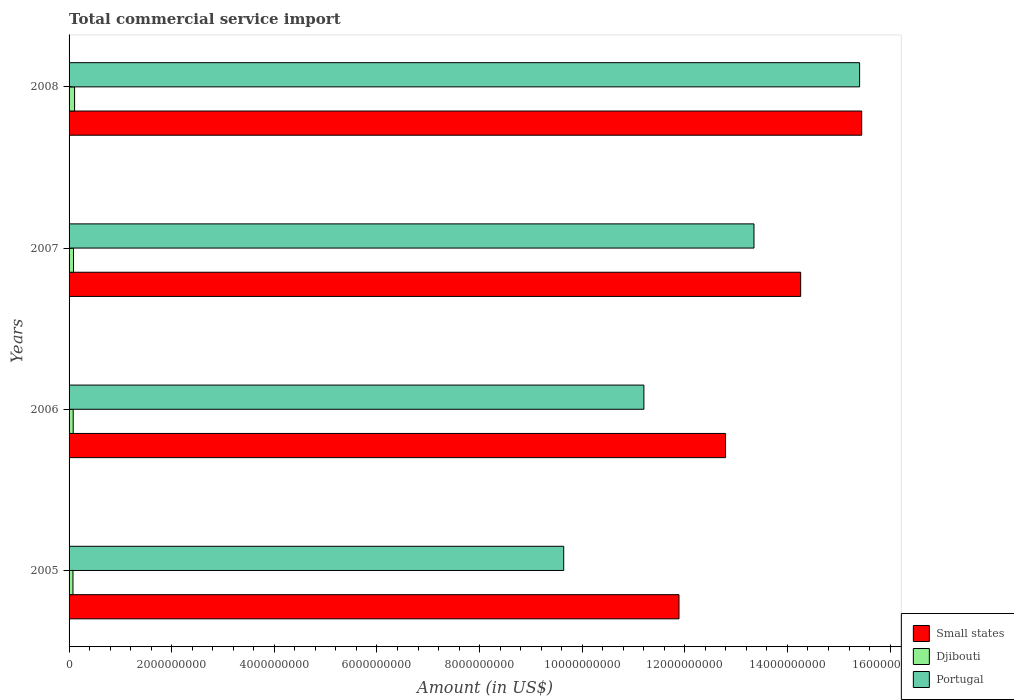How many different coloured bars are there?
Give a very brief answer. 3. How many groups of bars are there?
Keep it short and to the point. 4. Are the number of bars on each tick of the Y-axis equal?
Provide a short and direct response. Yes. How many bars are there on the 1st tick from the top?
Keep it short and to the point. 3. How many bars are there on the 2nd tick from the bottom?
Your answer should be very brief. 3. What is the label of the 1st group of bars from the top?
Offer a terse response. 2008. In how many cases, is the number of bars for a given year not equal to the number of legend labels?
Keep it short and to the point. 0. What is the total commercial service import in Small states in 2008?
Ensure brevity in your answer.  1.54e+1. Across all years, what is the maximum total commercial service import in Portugal?
Your answer should be very brief. 1.54e+1. Across all years, what is the minimum total commercial service import in Portugal?
Your answer should be very brief. 9.64e+09. In which year was the total commercial service import in Djibouti maximum?
Provide a short and direct response. 2008. In which year was the total commercial service import in Djibouti minimum?
Make the answer very short. 2005. What is the total total commercial service import in Portugal in the graph?
Your answer should be compact. 4.96e+1. What is the difference between the total commercial service import in Small states in 2005 and that in 2007?
Your answer should be compact. -2.37e+09. What is the difference between the total commercial service import in Small states in 2008 and the total commercial service import in Portugal in 2007?
Your answer should be very brief. 2.10e+09. What is the average total commercial service import in Djibouti per year?
Your answer should be compact. 8.77e+07. In the year 2006, what is the difference between the total commercial service import in Djibouti and total commercial service import in Small states?
Your answer should be compact. -1.27e+1. What is the ratio of the total commercial service import in Portugal in 2005 to that in 2006?
Your answer should be compact. 0.86. What is the difference between the highest and the second highest total commercial service import in Small states?
Provide a short and direct response. 1.19e+09. What is the difference between the highest and the lowest total commercial service import in Djibouti?
Give a very brief answer. 3.15e+07. What does the 3rd bar from the top in 2008 represents?
Provide a succinct answer. Small states. Are all the bars in the graph horizontal?
Ensure brevity in your answer.  Yes. Does the graph contain any zero values?
Your answer should be very brief. No. How many legend labels are there?
Your answer should be very brief. 3. How are the legend labels stacked?
Provide a succinct answer. Vertical. What is the title of the graph?
Offer a very short reply. Total commercial service import. What is the label or title of the X-axis?
Provide a succinct answer. Amount (in US$). What is the label or title of the Y-axis?
Provide a short and direct response. Years. What is the Amount (in US$) in Small states in 2005?
Keep it short and to the point. 1.19e+1. What is the Amount (in US$) in Djibouti in 2005?
Your answer should be compact. 7.61e+07. What is the Amount (in US$) in Portugal in 2005?
Offer a very short reply. 9.64e+09. What is the Amount (in US$) in Small states in 2006?
Your answer should be very brief. 1.28e+1. What is the Amount (in US$) of Djibouti in 2006?
Offer a terse response. 8.07e+07. What is the Amount (in US$) of Portugal in 2006?
Your response must be concise. 1.12e+1. What is the Amount (in US$) in Small states in 2007?
Offer a terse response. 1.43e+1. What is the Amount (in US$) in Djibouti in 2007?
Your response must be concise. 8.67e+07. What is the Amount (in US$) in Portugal in 2007?
Your answer should be compact. 1.33e+1. What is the Amount (in US$) of Small states in 2008?
Your answer should be compact. 1.54e+1. What is the Amount (in US$) of Djibouti in 2008?
Your answer should be compact. 1.08e+08. What is the Amount (in US$) of Portugal in 2008?
Offer a terse response. 1.54e+1. Across all years, what is the maximum Amount (in US$) of Small states?
Your response must be concise. 1.54e+1. Across all years, what is the maximum Amount (in US$) of Djibouti?
Provide a short and direct response. 1.08e+08. Across all years, what is the maximum Amount (in US$) of Portugal?
Give a very brief answer. 1.54e+1. Across all years, what is the minimum Amount (in US$) of Small states?
Offer a terse response. 1.19e+1. Across all years, what is the minimum Amount (in US$) of Djibouti?
Make the answer very short. 7.61e+07. Across all years, what is the minimum Amount (in US$) of Portugal?
Your answer should be very brief. 9.64e+09. What is the total Amount (in US$) in Small states in the graph?
Your answer should be very brief. 5.44e+1. What is the total Amount (in US$) in Djibouti in the graph?
Give a very brief answer. 3.51e+08. What is the total Amount (in US$) in Portugal in the graph?
Make the answer very short. 4.96e+1. What is the difference between the Amount (in US$) in Small states in 2005 and that in 2006?
Make the answer very short. -9.08e+08. What is the difference between the Amount (in US$) in Djibouti in 2005 and that in 2006?
Provide a succinct answer. -4.61e+06. What is the difference between the Amount (in US$) of Portugal in 2005 and that in 2006?
Your answer should be very brief. -1.56e+09. What is the difference between the Amount (in US$) in Small states in 2005 and that in 2007?
Your answer should be very brief. -2.37e+09. What is the difference between the Amount (in US$) in Djibouti in 2005 and that in 2007?
Give a very brief answer. -1.07e+07. What is the difference between the Amount (in US$) of Portugal in 2005 and that in 2007?
Your answer should be very brief. -3.71e+09. What is the difference between the Amount (in US$) of Small states in 2005 and that in 2008?
Your answer should be very brief. -3.56e+09. What is the difference between the Amount (in US$) in Djibouti in 2005 and that in 2008?
Provide a succinct answer. -3.15e+07. What is the difference between the Amount (in US$) of Portugal in 2005 and that in 2008?
Your response must be concise. -5.77e+09. What is the difference between the Amount (in US$) in Small states in 2006 and that in 2007?
Provide a short and direct response. -1.46e+09. What is the difference between the Amount (in US$) in Djibouti in 2006 and that in 2007?
Your answer should be compact. -6.04e+06. What is the difference between the Amount (in US$) in Portugal in 2006 and that in 2007?
Your answer should be very brief. -2.15e+09. What is the difference between the Amount (in US$) of Small states in 2006 and that in 2008?
Give a very brief answer. -2.65e+09. What is the difference between the Amount (in US$) of Djibouti in 2006 and that in 2008?
Give a very brief answer. -2.69e+07. What is the difference between the Amount (in US$) in Portugal in 2006 and that in 2008?
Your answer should be compact. -4.20e+09. What is the difference between the Amount (in US$) of Small states in 2007 and that in 2008?
Give a very brief answer. -1.19e+09. What is the difference between the Amount (in US$) of Djibouti in 2007 and that in 2008?
Your answer should be compact. -2.08e+07. What is the difference between the Amount (in US$) of Portugal in 2007 and that in 2008?
Your answer should be very brief. -2.06e+09. What is the difference between the Amount (in US$) in Small states in 2005 and the Amount (in US$) in Djibouti in 2006?
Your answer should be very brief. 1.18e+1. What is the difference between the Amount (in US$) of Small states in 2005 and the Amount (in US$) of Portugal in 2006?
Provide a short and direct response. 6.84e+08. What is the difference between the Amount (in US$) in Djibouti in 2005 and the Amount (in US$) in Portugal in 2006?
Your answer should be compact. -1.11e+1. What is the difference between the Amount (in US$) in Small states in 2005 and the Amount (in US$) in Djibouti in 2007?
Ensure brevity in your answer.  1.18e+1. What is the difference between the Amount (in US$) in Small states in 2005 and the Amount (in US$) in Portugal in 2007?
Make the answer very short. -1.46e+09. What is the difference between the Amount (in US$) of Djibouti in 2005 and the Amount (in US$) of Portugal in 2007?
Make the answer very short. -1.33e+1. What is the difference between the Amount (in US$) of Small states in 2005 and the Amount (in US$) of Djibouti in 2008?
Your answer should be compact. 1.18e+1. What is the difference between the Amount (in US$) of Small states in 2005 and the Amount (in US$) of Portugal in 2008?
Provide a succinct answer. -3.52e+09. What is the difference between the Amount (in US$) of Djibouti in 2005 and the Amount (in US$) of Portugal in 2008?
Offer a very short reply. -1.53e+1. What is the difference between the Amount (in US$) of Small states in 2006 and the Amount (in US$) of Djibouti in 2007?
Your answer should be very brief. 1.27e+1. What is the difference between the Amount (in US$) of Small states in 2006 and the Amount (in US$) of Portugal in 2007?
Provide a short and direct response. -5.54e+08. What is the difference between the Amount (in US$) of Djibouti in 2006 and the Amount (in US$) of Portugal in 2007?
Your response must be concise. -1.33e+1. What is the difference between the Amount (in US$) in Small states in 2006 and the Amount (in US$) in Djibouti in 2008?
Make the answer very short. 1.27e+1. What is the difference between the Amount (in US$) of Small states in 2006 and the Amount (in US$) of Portugal in 2008?
Your response must be concise. -2.61e+09. What is the difference between the Amount (in US$) in Djibouti in 2006 and the Amount (in US$) in Portugal in 2008?
Your answer should be compact. -1.53e+1. What is the difference between the Amount (in US$) of Small states in 2007 and the Amount (in US$) of Djibouti in 2008?
Provide a short and direct response. 1.41e+1. What is the difference between the Amount (in US$) of Small states in 2007 and the Amount (in US$) of Portugal in 2008?
Provide a succinct answer. -1.15e+09. What is the difference between the Amount (in US$) in Djibouti in 2007 and the Amount (in US$) in Portugal in 2008?
Give a very brief answer. -1.53e+1. What is the average Amount (in US$) in Small states per year?
Your response must be concise. 1.36e+1. What is the average Amount (in US$) of Djibouti per year?
Provide a short and direct response. 8.77e+07. What is the average Amount (in US$) of Portugal per year?
Keep it short and to the point. 1.24e+1. In the year 2005, what is the difference between the Amount (in US$) of Small states and Amount (in US$) of Djibouti?
Your answer should be very brief. 1.18e+1. In the year 2005, what is the difference between the Amount (in US$) in Small states and Amount (in US$) in Portugal?
Give a very brief answer. 2.25e+09. In the year 2005, what is the difference between the Amount (in US$) in Djibouti and Amount (in US$) in Portugal?
Keep it short and to the point. -9.56e+09. In the year 2006, what is the difference between the Amount (in US$) in Small states and Amount (in US$) in Djibouti?
Provide a short and direct response. 1.27e+1. In the year 2006, what is the difference between the Amount (in US$) in Small states and Amount (in US$) in Portugal?
Ensure brevity in your answer.  1.59e+09. In the year 2006, what is the difference between the Amount (in US$) in Djibouti and Amount (in US$) in Portugal?
Provide a succinct answer. -1.11e+1. In the year 2007, what is the difference between the Amount (in US$) of Small states and Amount (in US$) of Djibouti?
Your answer should be compact. 1.42e+1. In the year 2007, what is the difference between the Amount (in US$) of Small states and Amount (in US$) of Portugal?
Provide a succinct answer. 9.10e+08. In the year 2007, what is the difference between the Amount (in US$) of Djibouti and Amount (in US$) of Portugal?
Your answer should be compact. -1.33e+1. In the year 2008, what is the difference between the Amount (in US$) in Small states and Amount (in US$) in Djibouti?
Make the answer very short. 1.53e+1. In the year 2008, what is the difference between the Amount (in US$) of Small states and Amount (in US$) of Portugal?
Your answer should be compact. 4.07e+07. In the year 2008, what is the difference between the Amount (in US$) of Djibouti and Amount (in US$) of Portugal?
Keep it short and to the point. -1.53e+1. What is the ratio of the Amount (in US$) in Small states in 2005 to that in 2006?
Provide a succinct answer. 0.93. What is the ratio of the Amount (in US$) of Djibouti in 2005 to that in 2006?
Your response must be concise. 0.94. What is the ratio of the Amount (in US$) of Portugal in 2005 to that in 2006?
Your answer should be compact. 0.86. What is the ratio of the Amount (in US$) in Small states in 2005 to that in 2007?
Make the answer very short. 0.83. What is the ratio of the Amount (in US$) in Djibouti in 2005 to that in 2007?
Give a very brief answer. 0.88. What is the ratio of the Amount (in US$) of Portugal in 2005 to that in 2007?
Your response must be concise. 0.72. What is the ratio of the Amount (in US$) in Small states in 2005 to that in 2008?
Your response must be concise. 0.77. What is the ratio of the Amount (in US$) of Djibouti in 2005 to that in 2008?
Keep it short and to the point. 0.71. What is the ratio of the Amount (in US$) of Portugal in 2005 to that in 2008?
Ensure brevity in your answer.  0.63. What is the ratio of the Amount (in US$) of Small states in 2006 to that in 2007?
Ensure brevity in your answer.  0.9. What is the ratio of the Amount (in US$) in Djibouti in 2006 to that in 2007?
Provide a short and direct response. 0.93. What is the ratio of the Amount (in US$) of Portugal in 2006 to that in 2007?
Your response must be concise. 0.84. What is the ratio of the Amount (in US$) in Small states in 2006 to that in 2008?
Make the answer very short. 0.83. What is the ratio of the Amount (in US$) in Djibouti in 2006 to that in 2008?
Your answer should be very brief. 0.75. What is the ratio of the Amount (in US$) of Portugal in 2006 to that in 2008?
Make the answer very short. 0.73. What is the ratio of the Amount (in US$) in Small states in 2007 to that in 2008?
Your answer should be very brief. 0.92. What is the ratio of the Amount (in US$) of Djibouti in 2007 to that in 2008?
Your answer should be very brief. 0.81. What is the ratio of the Amount (in US$) in Portugal in 2007 to that in 2008?
Keep it short and to the point. 0.87. What is the difference between the highest and the second highest Amount (in US$) of Small states?
Ensure brevity in your answer.  1.19e+09. What is the difference between the highest and the second highest Amount (in US$) of Djibouti?
Your answer should be compact. 2.08e+07. What is the difference between the highest and the second highest Amount (in US$) in Portugal?
Offer a terse response. 2.06e+09. What is the difference between the highest and the lowest Amount (in US$) in Small states?
Provide a short and direct response. 3.56e+09. What is the difference between the highest and the lowest Amount (in US$) in Djibouti?
Offer a terse response. 3.15e+07. What is the difference between the highest and the lowest Amount (in US$) of Portugal?
Ensure brevity in your answer.  5.77e+09. 